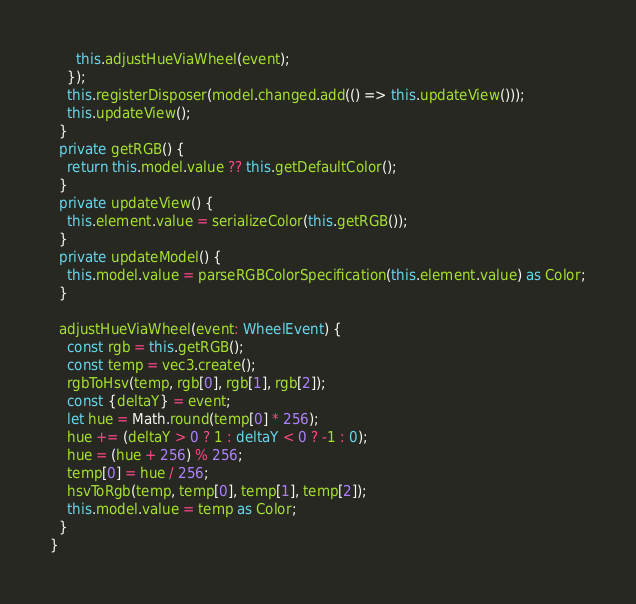<code> <loc_0><loc_0><loc_500><loc_500><_TypeScript_>      this.adjustHueViaWheel(event);
    });
    this.registerDisposer(model.changed.add(() => this.updateView()));
    this.updateView();
  }
  private getRGB() {
    return this.model.value ?? this.getDefaultColor();
  }
  private updateView() {
    this.element.value = serializeColor(this.getRGB());
  }
  private updateModel() {
    this.model.value = parseRGBColorSpecification(this.element.value) as Color;
  }

  adjustHueViaWheel(event: WheelEvent) {
    const rgb = this.getRGB();
    const temp = vec3.create();
    rgbToHsv(temp, rgb[0], rgb[1], rgb[2]);
    const {deltaY} = event;
    let hue = Math.round(temp[0] * 256);
    hue += (deltaY > 0 ? 1 : deltaY < 0 ? -1 : 0);
    hue = (hue + 256) % 256;
    temp[0] = hue / 256;
    hsvToRgb(temp, temp[0], temp[1], temp[2]);
    this.model.value = temp as Color;
  }
}
</code> 